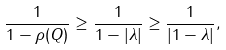<formula> <loc_0><loc_0><loc_500><loc_500>& \frac { 1 } { 1 - \rho ( Q ) } \geq \frac { 1 } { 1 - | \lambda | } \geq \frac { 1 } { | 1 - \lambda | } , &</formula> 